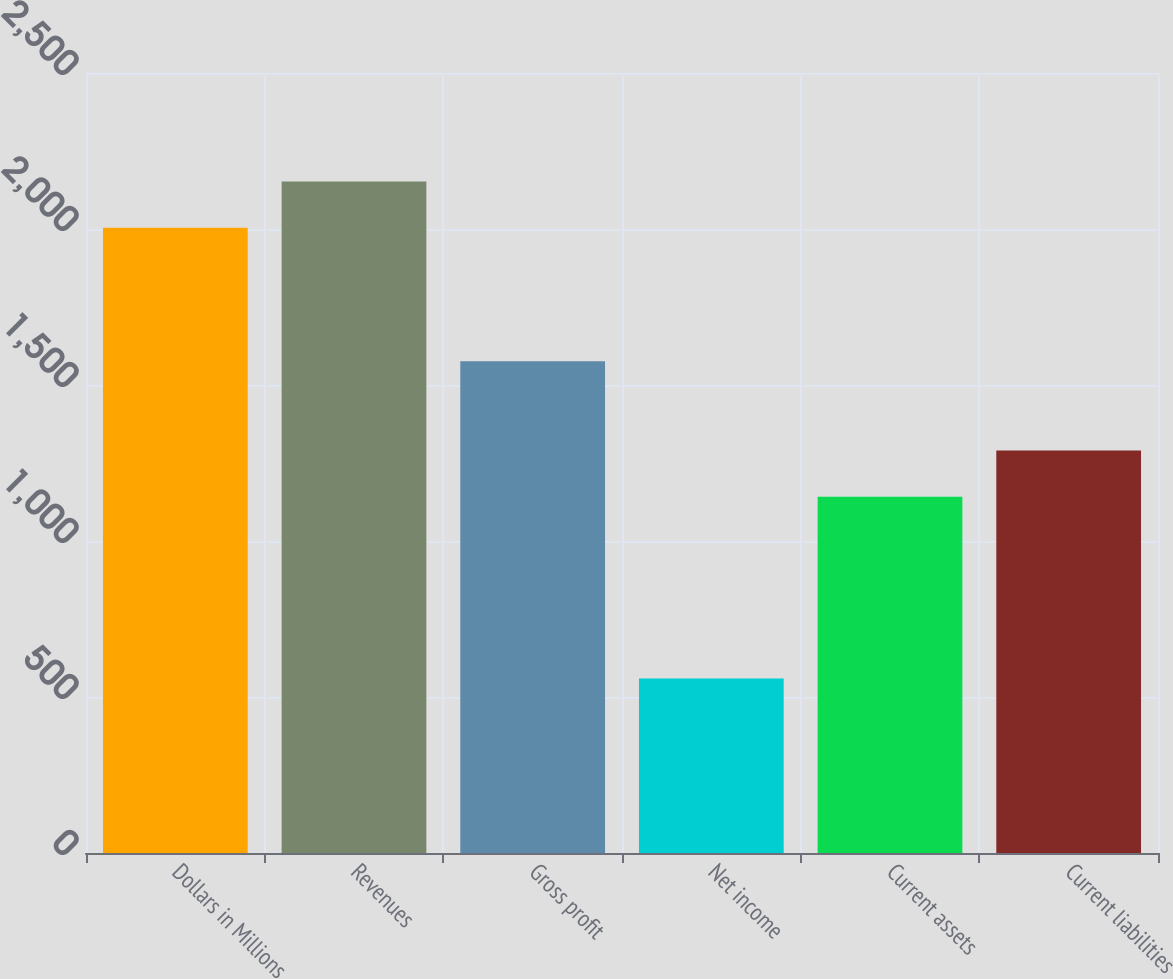<chart> <loc_0><loc_0><loc_500><loc_500><bar_chart><fcel>Dollars in Millions<fcel>Revenues<fcel>Gross profit<fcel>Net income<fcel>Current assets<fcel>Current liabilities<nl><fcel>2004<fcel>2151.9<fcel>1576<fcel>559<fcel>1142<fcel>1289.9<nl></chart> 